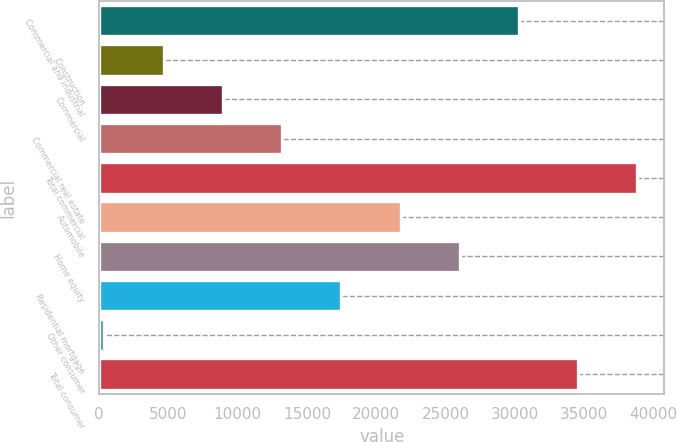Convert chart to OTSL. <chart><loc_0><loc_0><loc_500><loc_500><bar_chart><fcel>Commercial and industrial<fcel>Construction<fcel>Commercial<fcel>Commercial real estate<fcel>Total commercial<fcel>Automobile<fcel>Home equity<fcel>Residential mortgage<fcel>Other consumer<fcel>Total consumer<nl><fcel>30298<fcel>4654<fcel>8928<fcel>13202<fcel>38846<fcel>21750<fcel>26024<fcel>17476<fcel>380<fcel>34572<nl></chart> 